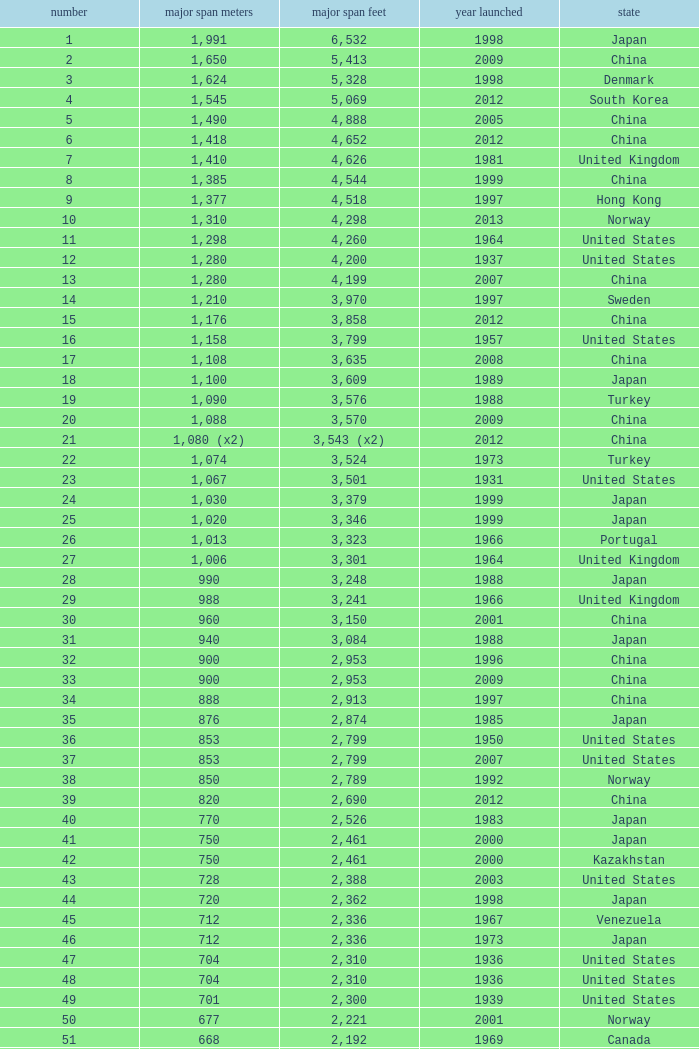What is the main span in feet from a year of 2009 or more recent with a rank less than 94 and 1,310 main span metres? 4298.0. 